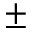Convert formula to latex. <formula><loc_0><loc_0><loc_500><loc_500>\pm</formula> 